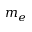<formula> <loc_0><loc_0><loc_500><loc_500>m _ { e }</formula> 